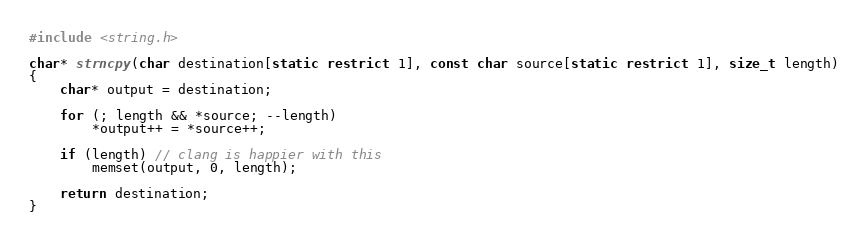<code> <loc_0><loc_0><loc_500><loc_500><_C_>#include <string.h>

char* strncpy(char destination[static restrict 1], const char source[static restrict 1], size_t length)
{
    char* output = destination;

    for (; length && *source; --length)
        *output++ = *source++;

    if (length) // clang is happier with this
        memset(output, 0, length);

    return destination;
}
</code> 